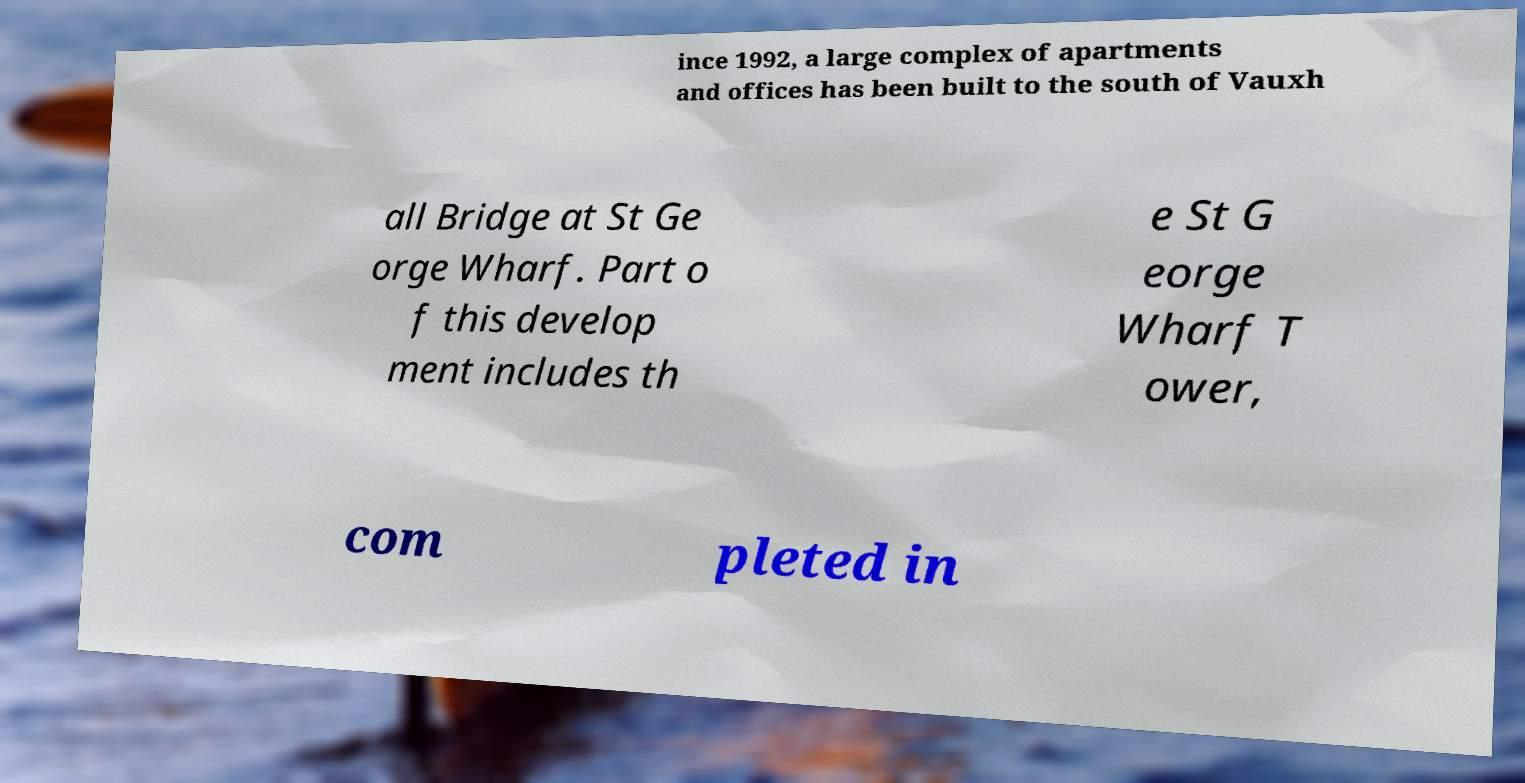Please identify and transcribe the text found in this image. ince 1992, a large complex of apartments and offices has been built to the south of Vauxh all Bridge at St Ge orge Wharf. Part o f this develop ment includes th e St G eorge Wharf T ower, com pleted in 